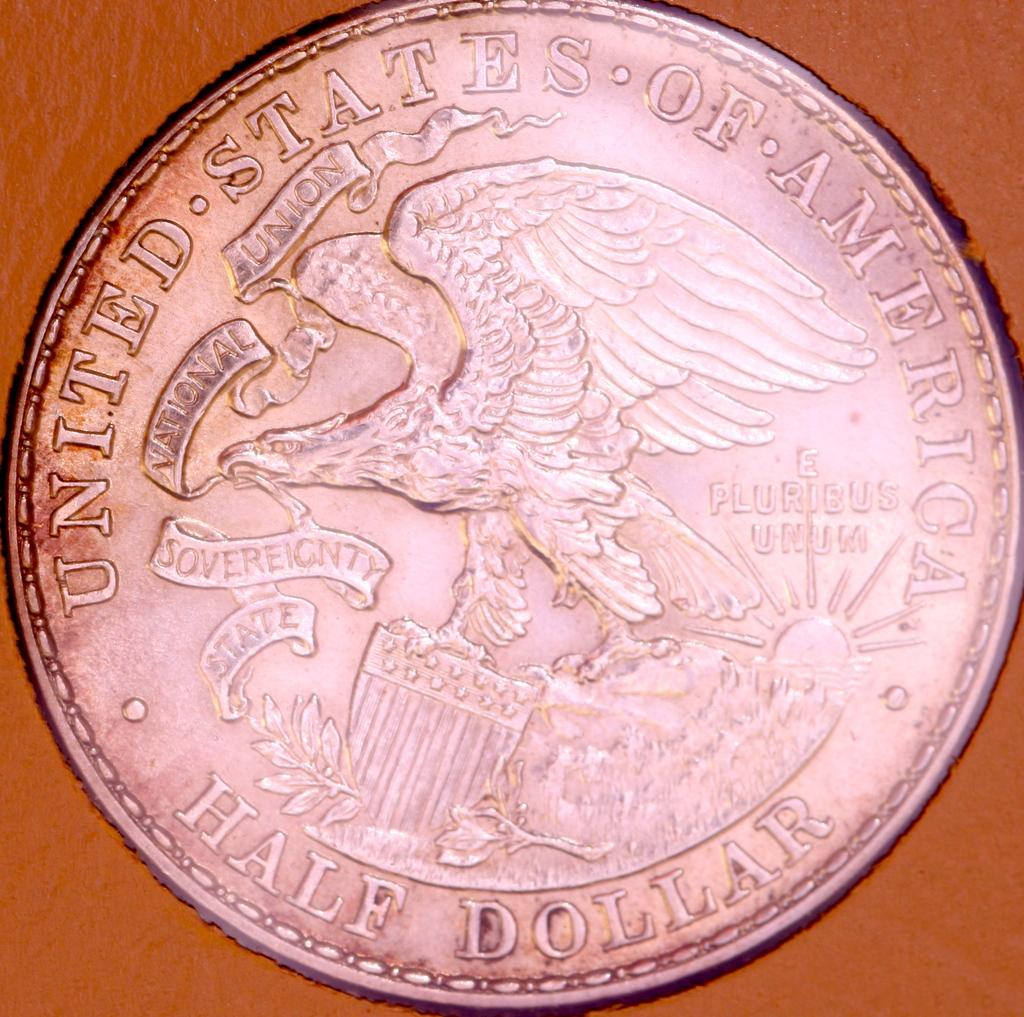How much is this coin worth?
Provide a succinct answer. Half dollar. 